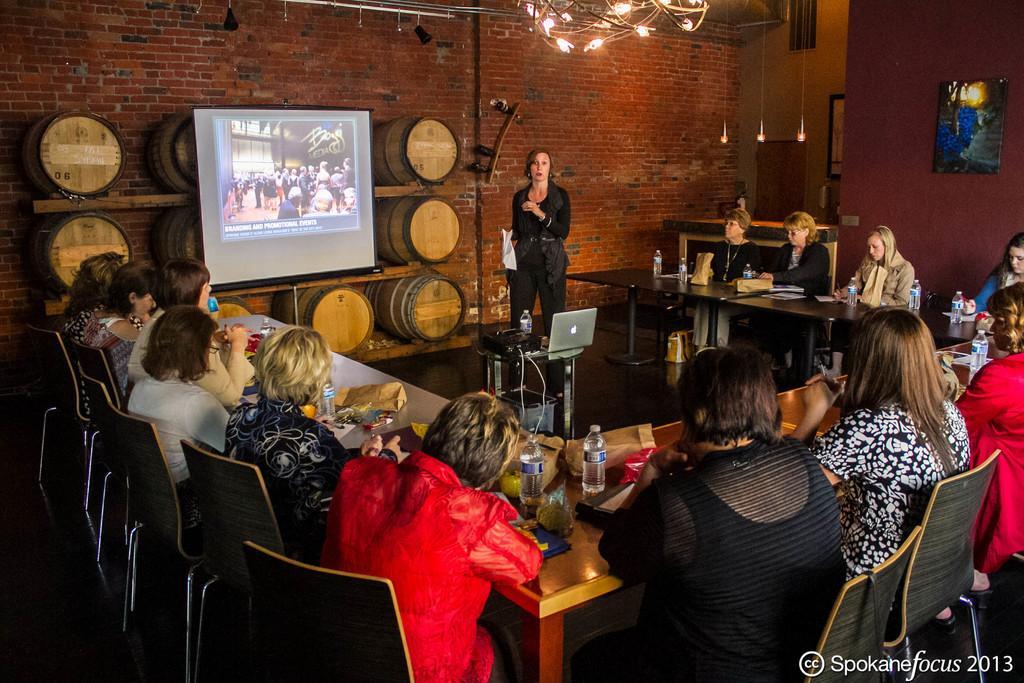Describe this image in one or two sentences. In this image few persons are sitting on the chairs before a table having few bottles, packets and few objects on it. A woman wearing a black dress is standing on the floor. There is a table having a laptop and a bottle on it. There are few wine drums attached to the red brick wall. On wine drums there is a display screen having an image. Top of image there are few lights. Right side there is a picture frame attached to the wall. 